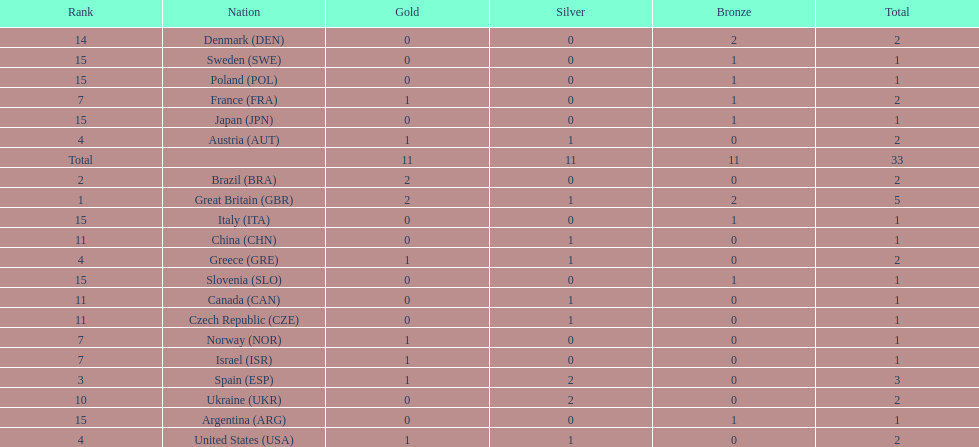What was the total number of medals won by united states? 2. 